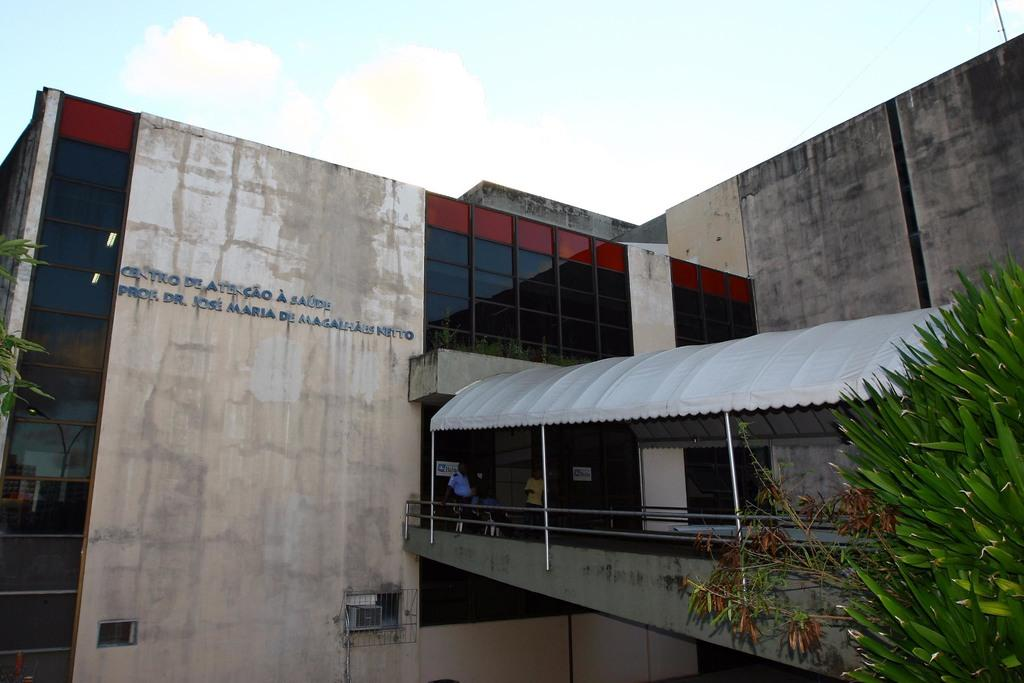What type of structure is visible in the image? There is a building in the image. What type of temporary shelter is also present in the image? There is a tent in the image. Can you describe the people in the image? There are persons in the image. What are the rods used for in the image? The rods are used for supporting the tent. What type of vegetation can be seen in the image? There are trees in the image. What type of barrier is present in the image? There is a wall in the image. What allows light to enter the building in the image? There are windows in the image. What is visible in the sky at the top of the image? Clouds are present in the sky. What type of paper is being used to measure the wealth of the persons in the image? There is no paper or indication of wealth in the image; it features a building, a tent, persons, rods, trees, a wall, windows, and clouds in the sky. 